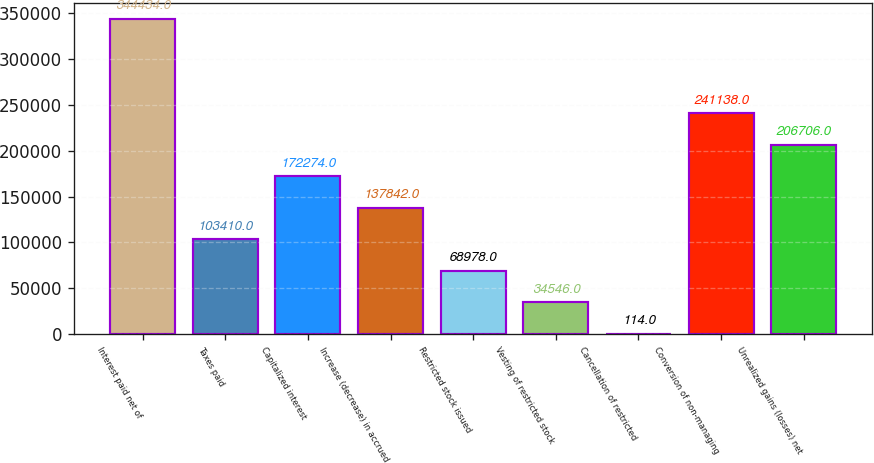Convert chart to OTSL. <chart><loc_0><loc_0><loc_500><loc_500><bar_chart><fcel>Interest paid net of<fcel>Taxes paid<fcel>Capitalized interest<fcel>Increase (decrease) in accrued<fcel>Restricted stock issued<fcel>Vesting of restricted stock<fcel>Cancellation of restricted<fcel>Conversion of non-managing<fcel>Unrealized gains (losses) net<nl><fcel>344434<fcel>103410<fcel>172274<fcel>137842<fcel>68978<fcel>34546<fcel>114<fcel>241138<fcel>206706<nl></chart> 